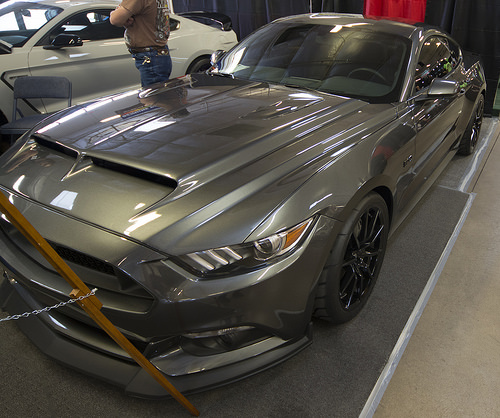<image>
Is the car above the surface? No. The car is not positioned above the surface. The vertical arrangement shows a different relationship. 